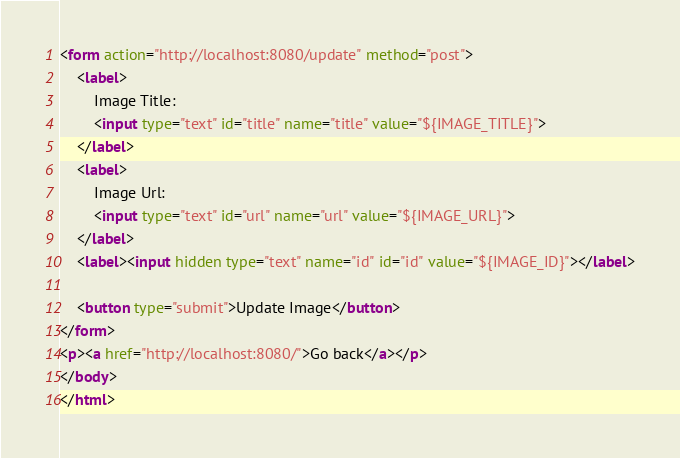Convert code to text. <code><loc_0><loc_0><loc_500><loc_500><_HTML_><form action="http://localhost:8080/update" method="post">
    <label>
        Image Title:
        <input type="text" id="title" name="title" value="${IMAGE_TITLE}">
    </label>
    <label>
        Image Url:
        <input type="text" id="url" name="url" value="${IMAGE_URL}">
    </label>
    <label><input hidden type="text" name="id" id="id" value="${IMAGE_ID}"></label>

    <button type="submit">Update Image</button>
</form>
<p><a href="http://localhost:8080/">Go back</a></p>
</body>
</html></code> 